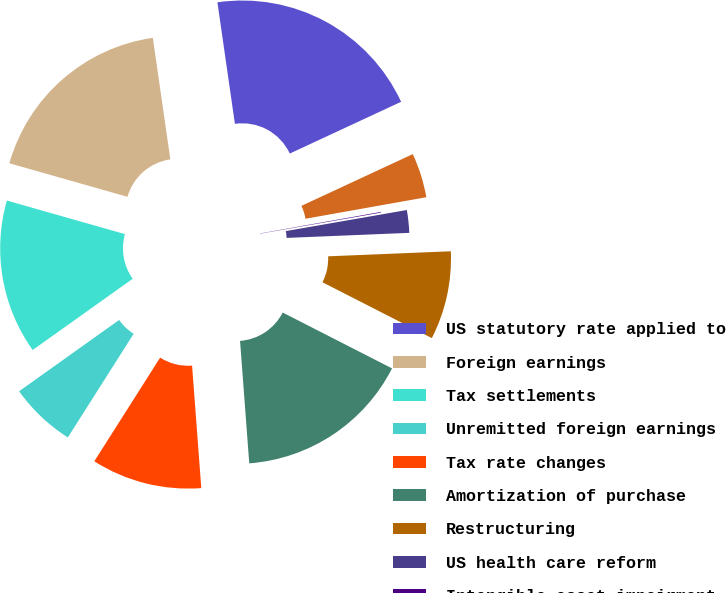Convert chart. <chart><loc_0><loc_0><loc_500><loc_500><pie_chart><fcel>US statutory rate applied to<fcel>Foreign earnings<fcel>Tax settlements<fcel>Unremitted foreign earnings<fcel>Tax rate changes<fcel>Amortization of purchase<fcel>Restructuring<fcel>US health care reform<fcel>Intangible asset impairment<fcel>State taxes<nl><fcel>20.35%<fcel>18.32%<fcel>14.26%<fcel>6.14%<fcel>10.2%<fcel>16.29%<fcel>8.17%<fcel>2.09%<fcel>0.06%<fcel>4.12%<nl></chart> 